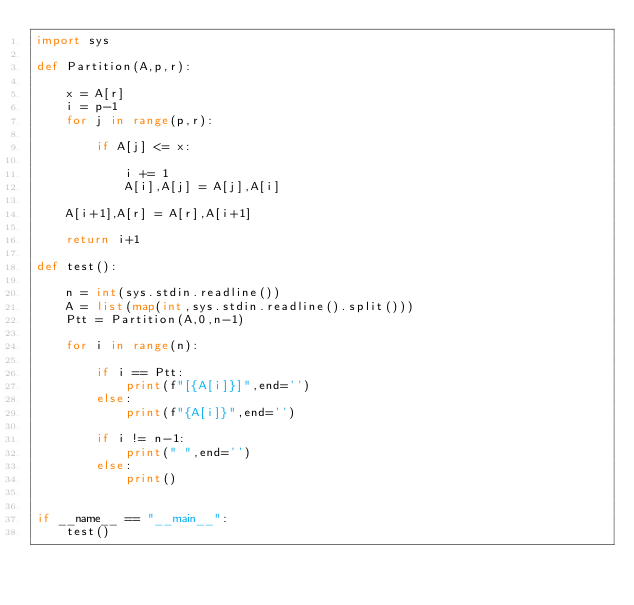Convert code to text. <code><loc_0><loc_0><loc_500><loc_500><_Python_>import sys

def Partition(A,p,r):

	x = A[r]
	i = p-1
	for j in range(p,r):

		if A[j] <= x:

			i += 1
			A[i],A[j] = A[j],A[i]

	A[i+1],A[r] = A[r],A[i+1]

	return i+1

def test():

	n = int(sys.stdin.readline())
	A = list(map(int,sys.stdin.readline().split()))
	Ptt = Partition(A,0,n-1)

	for i in range(n):

		if i == Ptt:
			print(f"[{A[i]}]",end='')
		else:
			print(f"{A[i]}",end='')

		if i != n-1:
			print(" ",end='')
		else:
			print()


if __name__ == "__main__":
	test()

</code> 